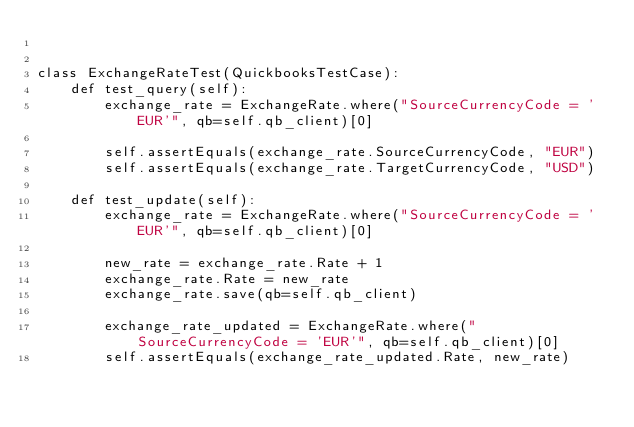<code> <loc_0><loc_0><loc_500><loc_500><_Python_>

class ExchangeRateTest(QuickbooksTestCase):
    def test_query(self):
        exchange_rate = ExchangeRate.where("SourceCurrencyCode = 'EUR'", qb=self.qb_client)[0]

        self.assertEquals(exchange_rate.SourceCurrencyCode, "EUR")
        self.assertEquals(exchange_rate.TargetCurrencyCode, "USD")

    def test_update(self):
        exchange_rate = ExchangeRate.where("SourceCurrencyCode = 'EUR'", qb=self.qb_client)[0]

        new_rate = exchange_rate.Rate + 1
        exchange_rate.Rate = new_rate
        exchange_rate.save(qb=self.qb_client)

        exchange_rate_updated = ExchangeRate.where("SourceCurrencyCode = 'EUR'", qb=self.qb_client)[0]
        self.assertEquals(exchange_rate_updated.Rate, new_rate)
</code> 